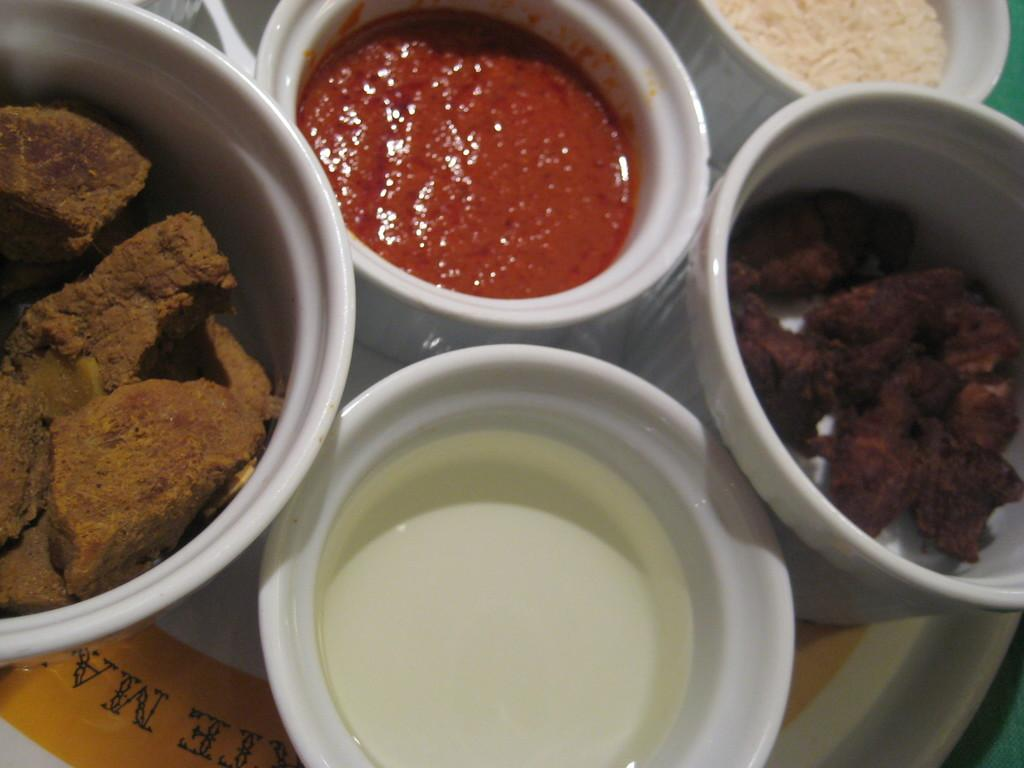What piece of furniture is present in the image? There is a table in the image. What is placed on the table? There is a plate on the table. What is on the plate? There are bowls on the plate. What is inside the bowls? The bowls contain liquids and food items. What type of engine can be seen powering the dolls in the image? There are no engines or dolls present in the image. How many pins are visible in the image? There is no mention of pins in the image, so it cannot be determined how many, if any, are present. 